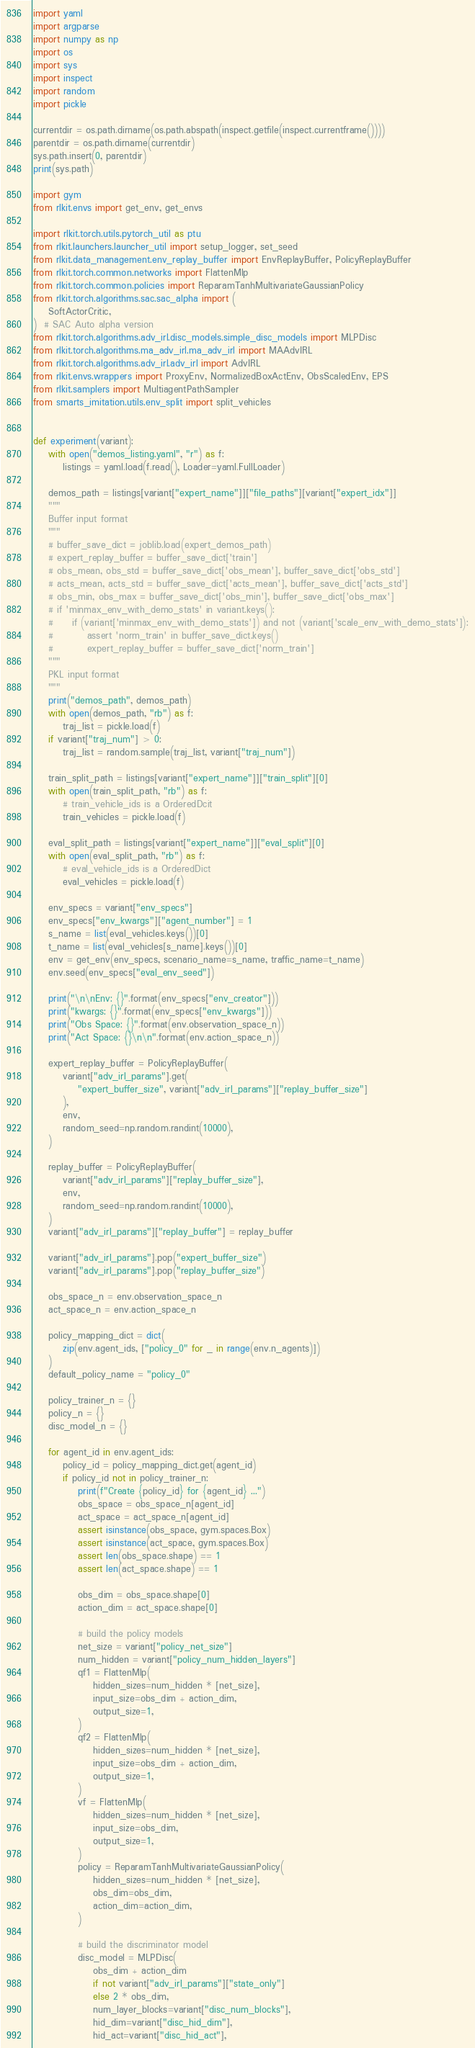<code> <loc_0><loc_0><loc_500><loc_500><_Python_>import yaml
import argparse
import numpy as np
import os
import sys
import inspect
import random
import pickle

currentdir = os.path.dirname(os.path.abspath(inspect.getfile(inspect.currentframe())))
parentdir = os.path.dirname(currentdir)
sys.path.insert(0, parentdir)
print(sys.path)

import gym
from rlkit.envs import get_env, get_envs

import rlkit.torch.utils.pytorch_util as ptu
from rlkit.launchers.launcher_util import setup_logger, set_seed
from rlkit.data_management.env_replay_buffer import EnvReplayBuffer, PolicyReplayBuffer
from rlkit.torch.common.networks import FlattenMlp
from rlkit.torch.common.policies import ReparamTanhMultivariateGaussianPolicy
from rlkit.torch.algorithms.sac.sac_alpha import (
    SoftActorCritic,
)  # SAC Auto alpha version
from rlkit.torch.algorithms.adv_irl.disc_models.simple_disc_models import MLPDisc
from rlkit.torch.algorithms.ma_adv_irl.ma_adv_irl import MAAdvIRL
from rlkit.torch.algorithms.adv_irl.adv_irl import AdvIRL
from rlkit.envs.wrappers import ProxyEnv, NormalizedBoxActEnv, ObsScaledEnv, EPS
from rlkit.samplers import MultiagentPathSampler
from smarts_imitation.utils.env_split import split_vehicles


def experiment(variant):
    with open("demos_listing.yaml", "r") as f:
        listings = yaml.load(f.read(), Loader=yaml.FullLoader)

    demos_path = listings[variant["expert_name"]]["file_paths"][variant["expert_idx"]]
    """
    Buffer input format
    """
    # buffer_save_dict = joblib.load(expert_demos_path)
    # expert_replay_buffer = buffer_save_dict['train']
    # obs_mean, obs_std = buffer_save_dict['obs_mean'], buffer_save_dict['obs_std']
    # acts_mean, acts_std = buffer_save_dict['acts_mean'], buffer_save_dict['acts_std']
    # obs_min, obs_max = buffer_save_dict['obs_min'], buffer_save_dict['obs_max']
    # if 'minmax_env_with_demo_stats' in variant.keys():
    #     if (variant['minmax_env_with_demo_stats']) and not (variant['scale_env_with_demo_stats']):
    #         assert 'norm_train' in buffer_save_dict.keys()
    #         expert_replay_buffer = buffer_save_dict['norm_train']
    """
    PKL input format
    """
    print("demos_path", demos_path)
    with open(demos_path, "rb") as f:
        traj_list = pickle.load(f)
    if variant["traj_num"] > 0:
        traj_list = random.sample(traj_list, variant["traj_num"])

    train_split_path = listings[variant["expert_name"]]["train_split"][0]
    with open(train_split_path, "rb") as f:
        # train_vehicle_ids is a OrderedDcit
        train_vehicles = pickle.load(f)

    eval_split_path = listings[variant["expert_name"]]["eval_split"][0]
    with open(eval_split_path, "rb") as f:
        # eval_vehicle_ids is a OrderedDict
        eval_vehicles = pickle.load(f)

    env_specs = variant["env_specs"]
    env_specs["env_kwargs"]["agent_number"] = 1
    s_name = list(eval_vehicles.keys())[0]
    t_name = list(eval_vehicles[s_name].keys())[0]
    env = get_env(env_specs, scenario_name=s_name, traffic_name=t_name)
    env.seed(env_specs["eval_env_seed"])

    print("\n\nEnv: {}".format(env_specs["env_creator"]))
    print("kwargs: {}".format(env_specs["env_kwargs"]))
    print("Obs Space: {}".format(env.observation_space_n))
    print("Act Space: {}\n\n".format(env.action_space_n))

    expert_replay_buffer = PolicyReplayBuffer(
        variant["adv_irl_params"].get(
            "expert_buffer_size", variant["adv_irl_params"]["replay_buffer_size"]
        ),
        env,
        random_seed=np.random.randint(10000),
    )

    replay_buffer = PolicyReplayBuffer(
        variant["adv_irl_params"]["replay_buffer_size"],
        env,
        random_seed=np.random.randint(10000),
    )
    variant["adv_irl_params"]["replay_buffer"] = replay_buffer

    variant["adv_irl_params"].pop("expert_buffer_size")
    variant["adv_irl_params"].pop("replay_buffer_size")

    obs_space_n = env.observation_space_n
    act_space_n = env.action_space_n

    policy_mapping_dict = dict(
        zip(env.agent_ids, ["policy_0" for _ in range(env.n_agents)])
    )
    default_policy_name = "policy_0"

    policy_trainer_n = {}
    policy_n = {}
    disc_model_n = {}

    for agent_id in env.agent_ids:
        policy_id = policy_mapping_dict.get(agent_id)
        if policy_id not in policy_trainer_n:
            print(f"Create {policy_id} for {agent_id} ...")
            obs_space = obs_space_n[agent_id]
            act_space = act_space_n[agent_id]
            assert isinstance(obs_space, gym.spaces.Box)
            assert isinstance(act_space, gym.spaces.Box)
            assert len(obs_space.shape) == 1
            assert len(act_space.shape) == 1

            obs_dim = obs_space.shape[0]
            action_dim = act_space.shape[0]

            # build the policy models
            net_size = variant["policy_net_size"]
            num_hidden = variant["policy_num_hidden_layers"]
            qf1 = FlattenMlp(
                hidden_sizes=num_hidden * [net_size],
                input_size=obs_dim + action_dim,
                output_size=1,
            )
            qf2 = FlattenMlp(
                hidden_sizes=num_hidden * [net_size],
                input_size=obs_dim + action_dim,
                output_size=1,
            )
            vf = FlattenMlp(
                hidden_sizes=num_hidden * [net_size],
                input_size=obs_dim,
                output_size=1,
            )
            policy = ReparamTanhMultivariateGaussianPolicy(
                hidden_sizes=num_hidden * [net_size],
                obs_dim=obs_dim,
                action_dim=action_dim,
            )

            # build the discriminator model
            disc_model = MLPDisc(
                obs_dim + action_dim
                if not variant["adv_irl_params"]["state_only"]
                else 2 * obs_dim,
                num_layer_blocks=variant["disc_num_blocks"],
                hid_dim=variant["disc_hid_dim"],
                hid_act=variant["disc_hid_act"],</code> 